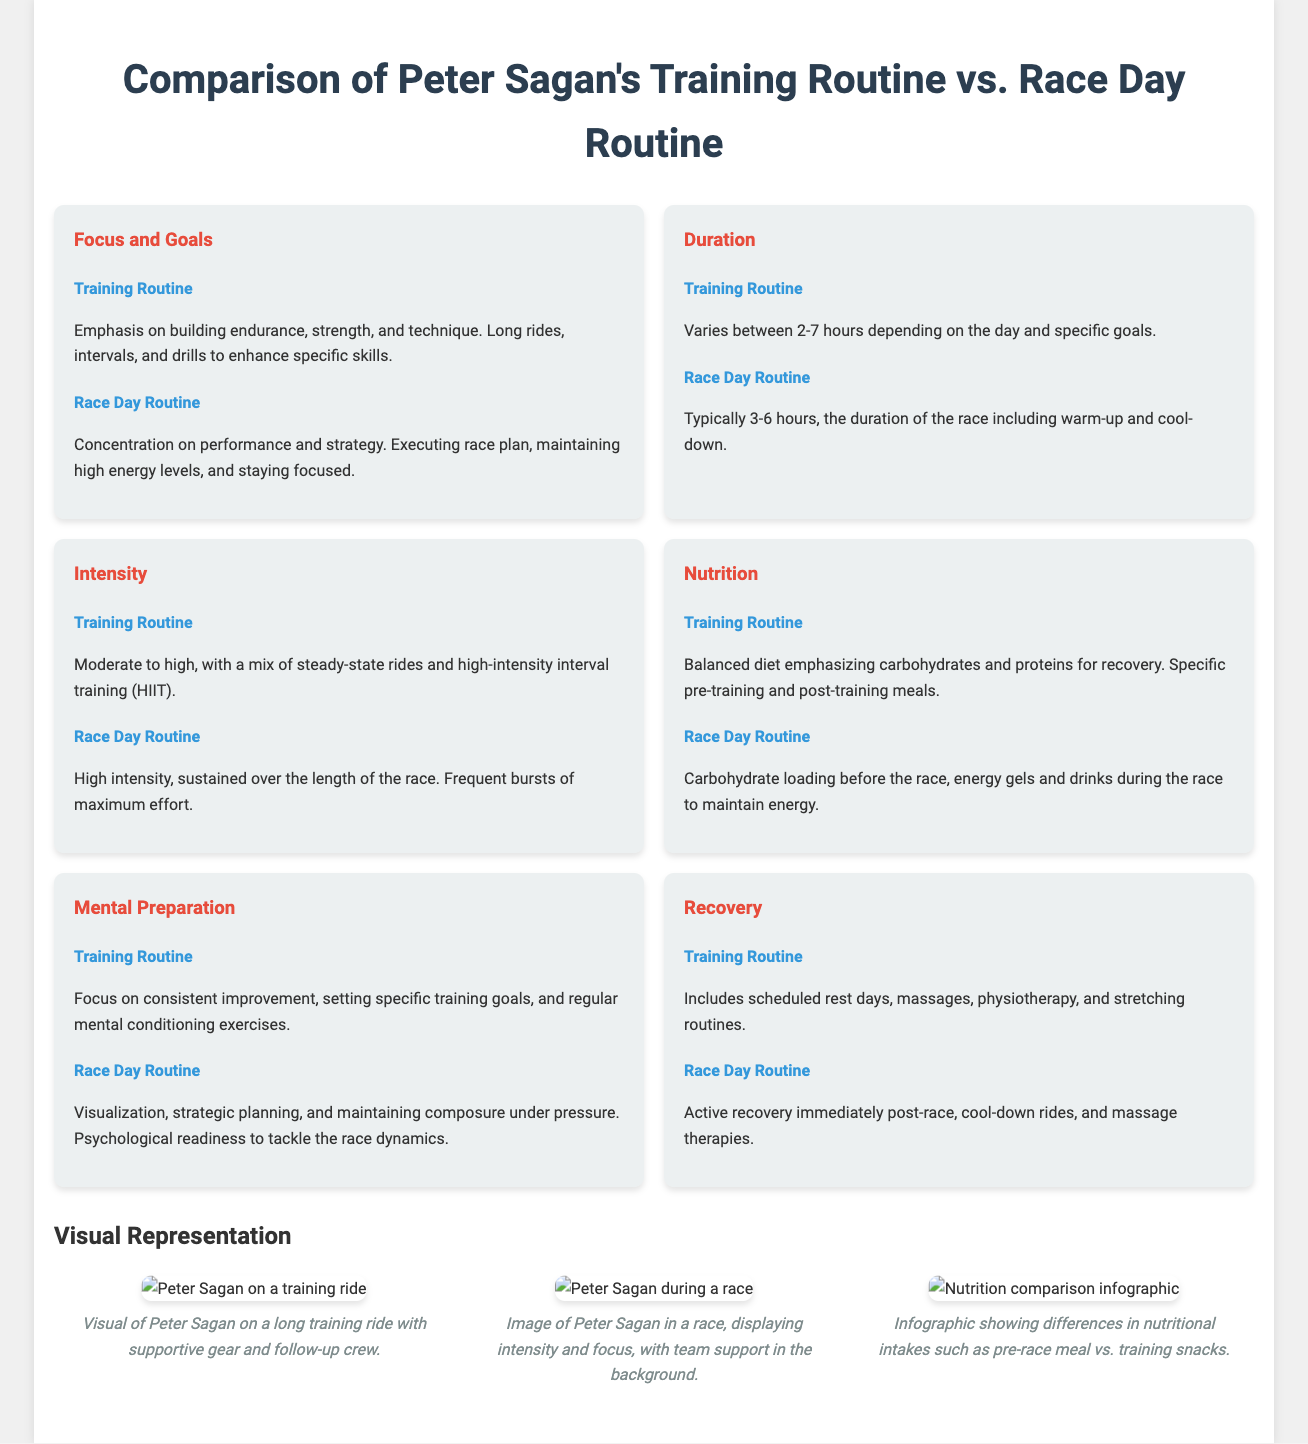what is the main focus of Sagan's training routine? The training routine emphasizes building endurance, strength, and technique.
Answer: endurance, strength, and technique how long does Sagan typically train? Training duration varies between 2-7 hours depending on the day and specific goals.
Answer: 2-7 hours what is the intensity level of Sagan's race day routine? The race day routine is characterized by high intensity sustained over the length of the race.
Answer: high intensity what type of nutrition does Sagan focus on during training? His training routine includes a balanced diet emphasizing carbohydrates and proteins for recovery.
Answer: balanced diet, carbohydrates, and proteins what mental preparation technique does Sagan use before races? On race day, he focuses on visualization, strategic planning, and maintaining composure under pressure.
Answer: visualization, strategic planning how does Sagan's post-race recovery differ from his training recovery? Post-race recovery includes active recovery immediately, while training recovery involves scheduled rest days and therapies.
Answer: active recovery, scheduled rest days what is the expected duration of a typical race? The race day routine usually lasts between 3-6 hours, including warm-up and cool-down.
Answer: 3-6 hours what is an example of nutrition during race day? He focuses on carbohydrate loading before the race and energy gels during the race.
Answer: carbohydrate loading, energy gels what kind of rides does Sagan include in his training? His training routine includes long rides, intervals, and drills to enhance specific skills.
Answer: long rides, intervals, drills 